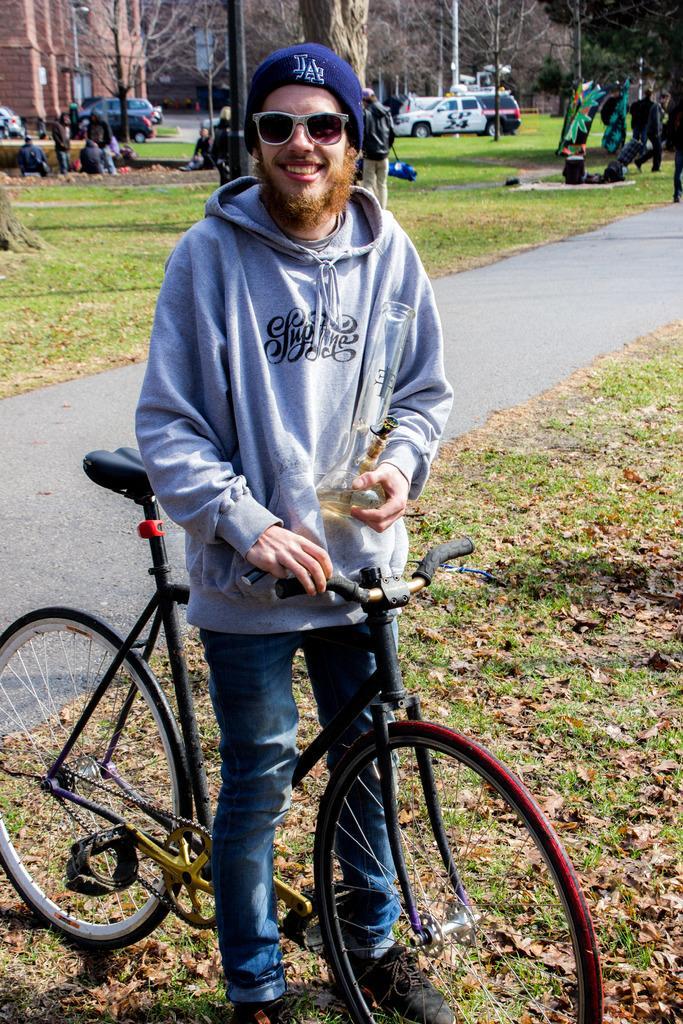Can you describe this image briefly? In this image there is a man standing near the bicycle by holding a bottle in his hand, and in back ground there is a grass,tree, car , group of people standing , building. 